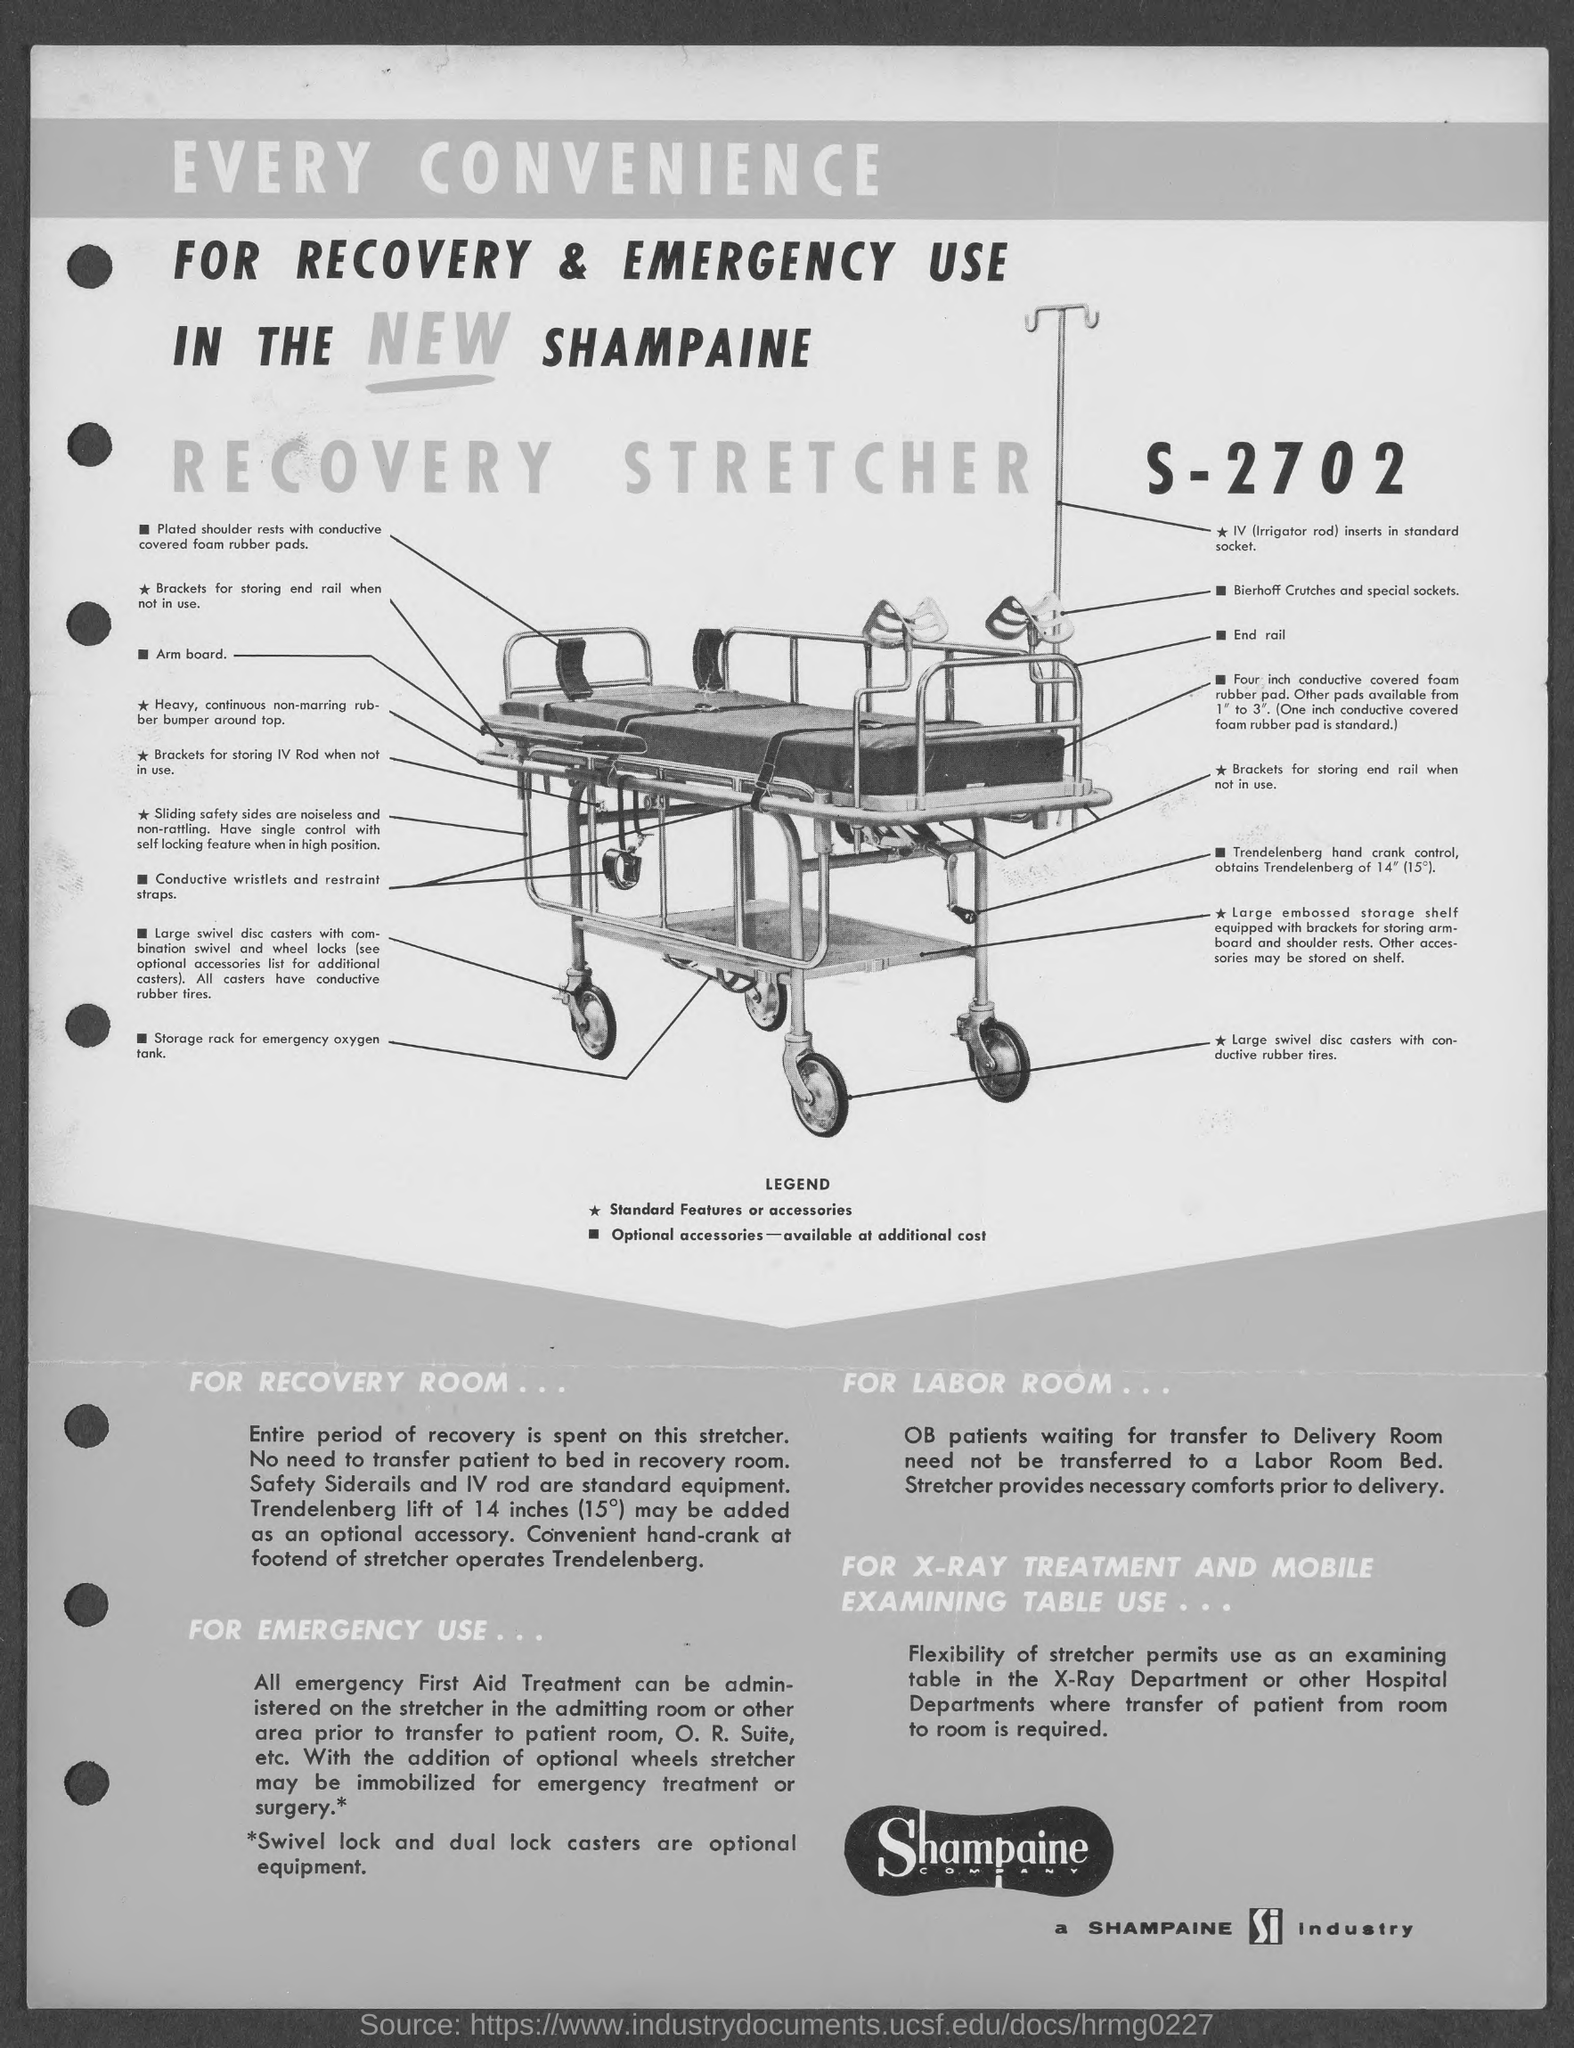Draw attention to some important aspects in this diagram. The third title in the document is 'IN THE NEW SHAMPAINE.' The fourth title in the document is 'RECOVERY STRETCHER.' The document contains a number at the top right corner, which is S-2702. The second title in the document is FOR RECOVERY & EMERGENCY USE. The first title in the document is 'EVERY CONVENIENCE...' 